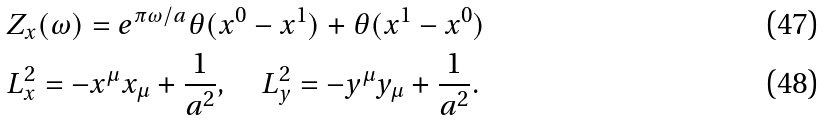<formula> <loc_0><loc_0><loc_500><loc_500>& Z _ { x } ( \omega ) = e ^ { \pi \omega / a } \theta ( x ^ { 0 } - x ^ { 1 } ) + \theta ( x ^ { 1 } - x ^ { 0 } ) \\ & L _ { x } ^ { 2 } = - x ^ { \mu } x _ { \mu } + \frac { 1 } { a ^ { 2 } } , \quad L _ { y } ^ { 2 } = - y ^ { \mu } y _ { \mu } + \frac { 1 } { a ^ { 2 } } .</formula> 